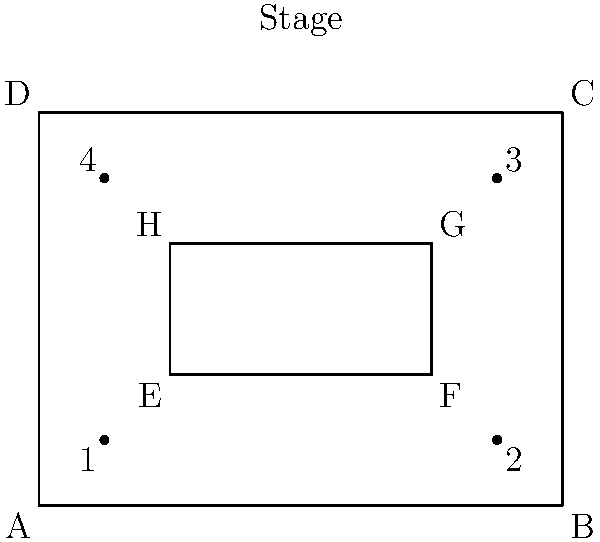In this diagram of a theater where Barbra Streisand has performed, rectangle ABCD represents the entire seating area, and rectangle EFGH represents the VIP section. If $\overline{AE} \cong \overline{BF}$ and $\overline{DH} \cong \overline{CG}$, prove that quadrilaterals AEHD and BFGC are congruent. To prove that quadrilaterals AEHD and BFGC are congruent, we'll use the Side-Angle-Side (SAS) congruence criterion. Let's follow these steps:

1) Given: $\overline{AE} \cong \overline{BF}$ and $\overline{DH} \cong \overline{CG}$

2) $\overline{AD} \cong \overline{BC}$ (opposite sides of rectangle ABCD)

3) $\angle DAE \cong \angle CBF$ (both are right angles in a rectangle)

4) Now we have:
   - $\overline{AE} \cong \overline{BF}$ (given)
   - $\angle DAE \cong \angle CBF$ (proved in step 3)
   - $\overline{AD} \cong \overline{BC}$ (proved in step 2)

5) By the SAS congruence criterion, triangle AED $\cong$ triangle BFC

6) This implies:
   - $\overline{ED} \cong \overline{FC}$
   - $\angle AED \cong \angle BFC$

7) We also know $\overline{DH} \cong \overline{CG}$ (given)

8) Now for triangles EDH and FCG:
   - $\overline{ED} \cong \overline{FC}$ (from step 6)
   - $\angle EDH \cong \angle FCG$ (supplementary to congruent angles from step 6)
   - $\overline{DH} \cong \overline{CG}$ (given)

9) By the SAS congruence criterion, triangle EDH $\cong$ triangle FCG

Therefore, quadrilaterals AEHD and BFGC are congruent as they are composed of congruent triangles (AED $\cong$ BFC and EDH $\cong$ FCG).
Answer: AEHD $\cong$ BFGC 